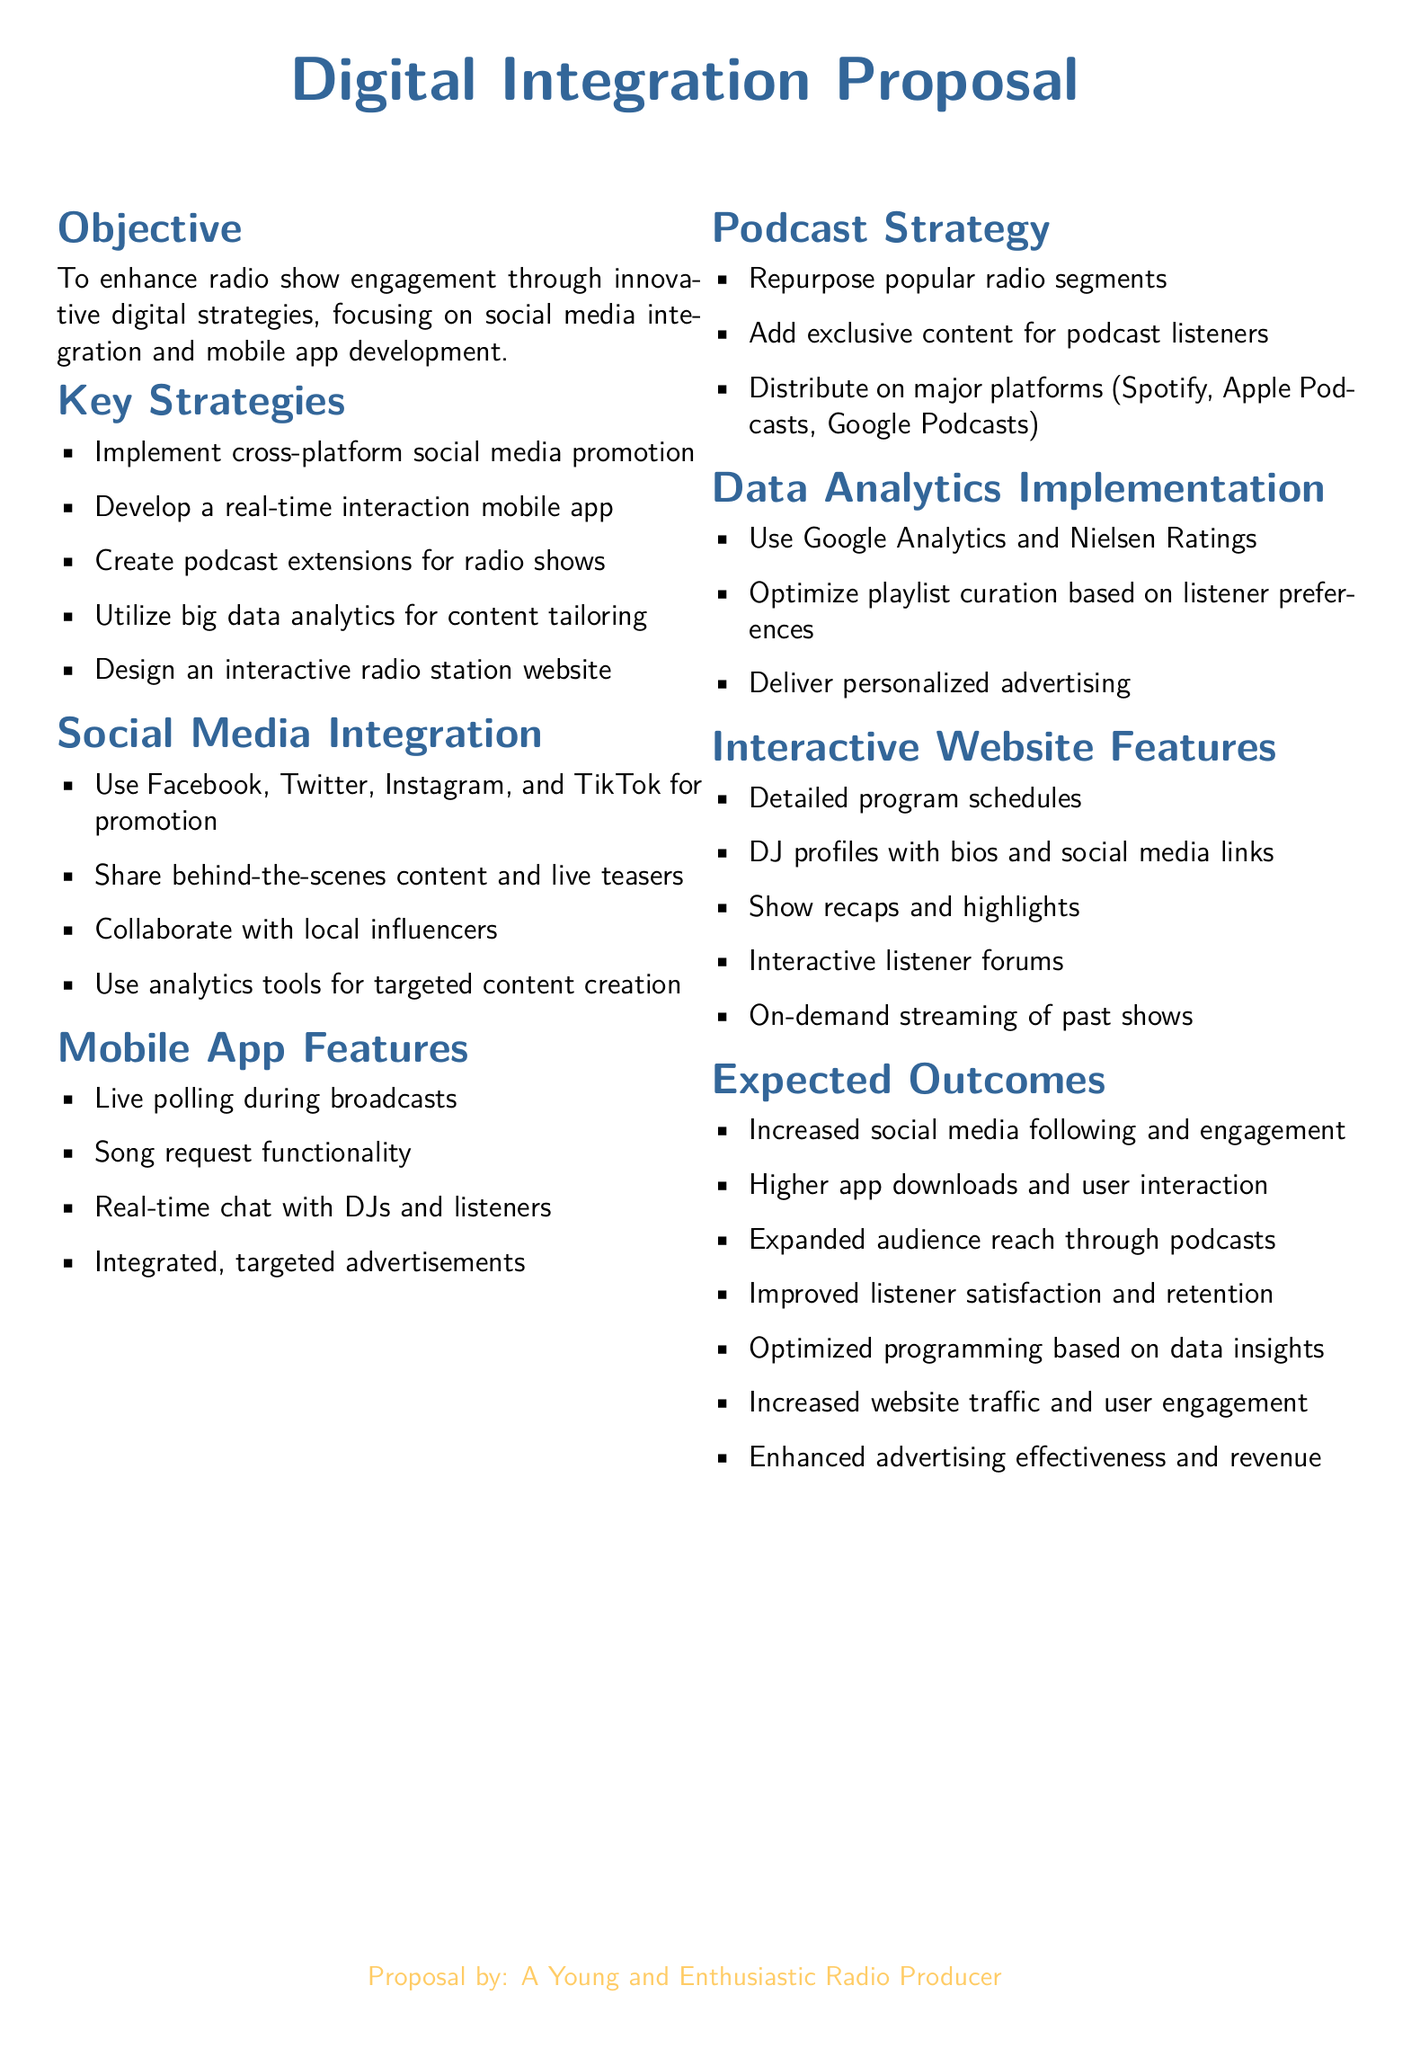What is the main objective of the proposal? The main objective is to enhance radio show engagement through innovative digital strategies.
Answer: Enhance radio show engagement through innovative digital strategies How many key strategies are outlined in the proposal? The document states a total of five key strategies for enhancing engagement.
Answer: Five Which social media platforms are mentioned for promotion? The proposal lists Facebook, Twitter, Instagram, and TikTok as the platforms for promotion.
Answer: Facebook, Twitter, Instagram, and TikTok What feature allows listeners to interact with the DJs? The proposal mentions a real-time chat feature for interaction during the broadcasts.
Answer: Real-time chat What is one expected outcome from the implementations described? The document lists increased social media following and engagement as one of the expected outcomes.
Answer: Increased social media following and engagement Which analytics tools are suggested for understanding listener preferences? Google Analytics and Nielsen Ratings are proposed as tools for implementing data analytics.
Answer: Google Analytics and Nielsen Ratings Name one of the additional features for the mobile app. One of the features listed for the mobile app is live polling during broadcasts.
Answer: Live polling during broadcasts What type of content will be repurposed for podcasts? The proposal states that popular radio segments will be repurposed for the podcast extensions.
Answer: Popular radio segments 